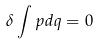<formula> <loc_0><loc_0><loc_500><loc_500>\delta \int p d q = 0</formula> 